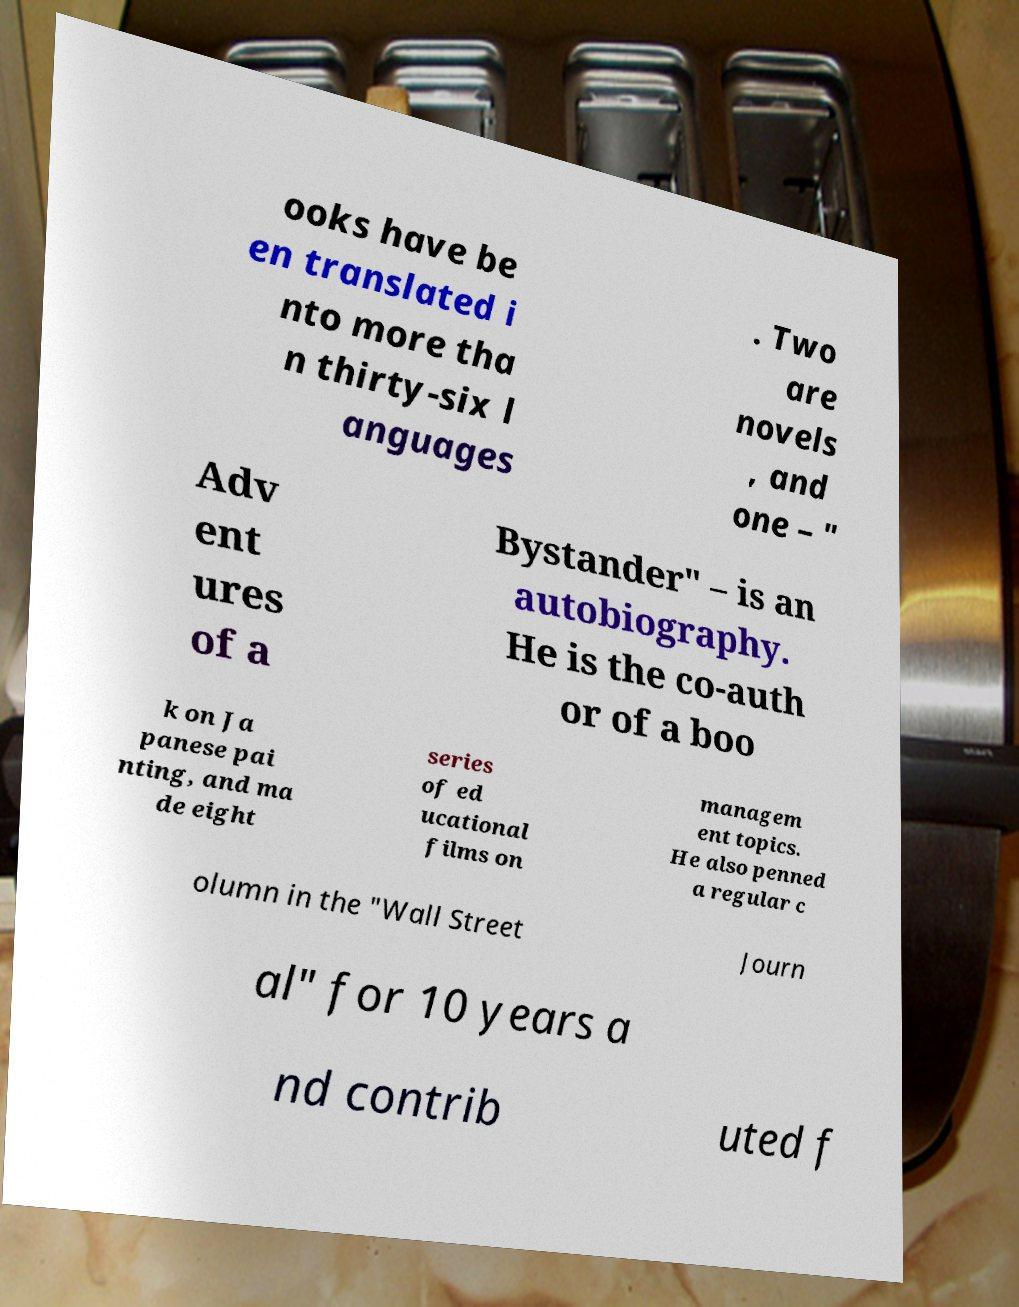I need the written content from this picture converted into text. Can you do that? ooks have be en translated i nto more tha n thirty-six l anguages . Two are novels , and one – " Adv ent ures of a Bystander" – is an autobiography. He is the co-auth or of a boo k on Ja panese pai nting, and ma de eight series of ed ucational films on managem ent topics. He also penned a regular c olumn in the "Wall Street Journ al" for 10 years a nd contrib uted f 